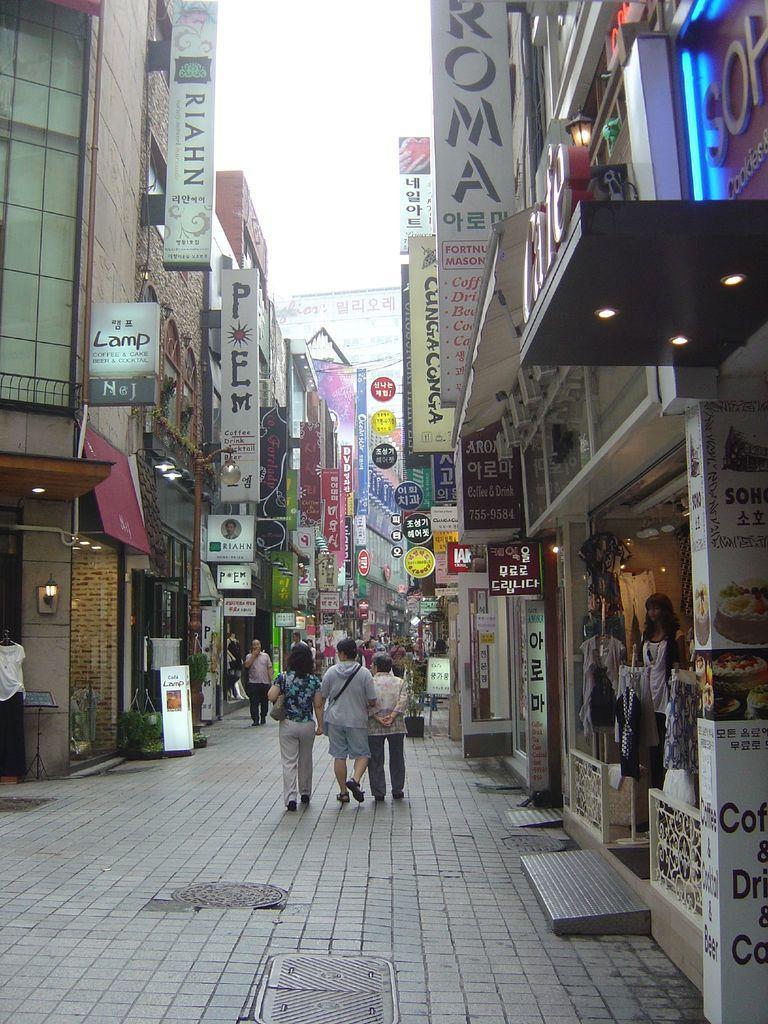Could you give a brief overview of what you see in this image? In this image we can see a few buildings, there are some potted plants, lights, people, clothes and boards with text on it, in the background, we can see the sky. 